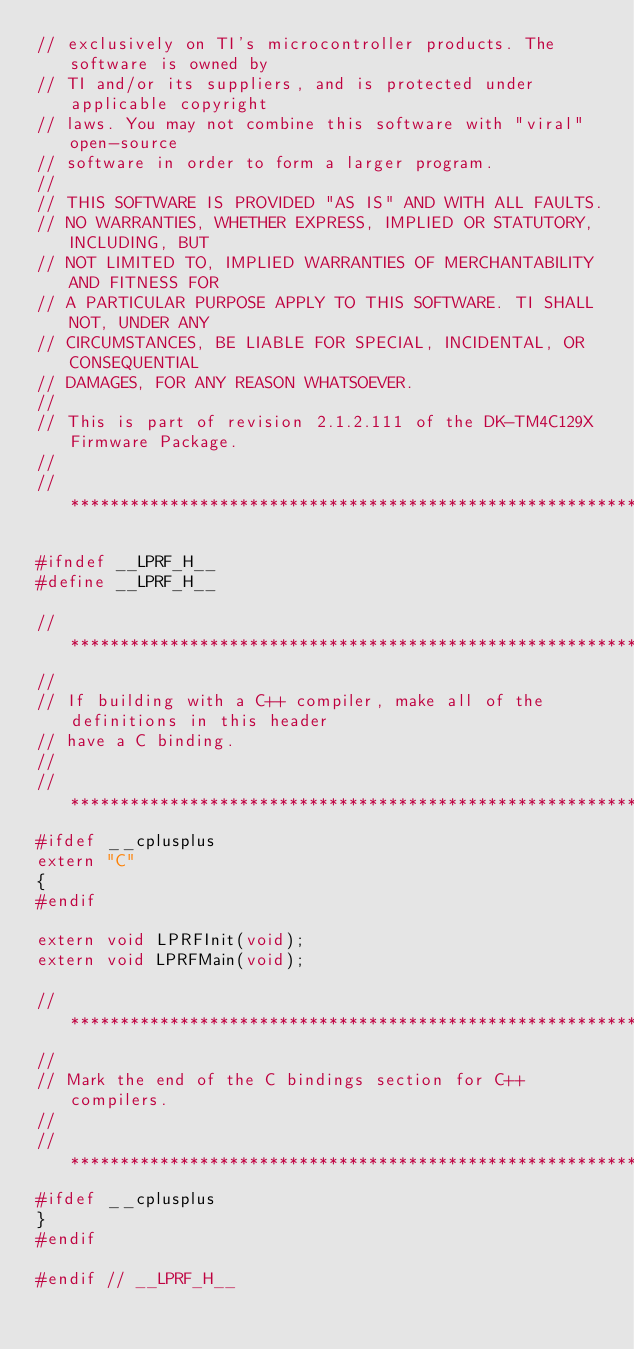<code> <loc_0><loc_0><loc_500><loc_500><_C_>// exclusively on TI's microcontroller products. The software is owned by
// TI and/or its suppliers, and is protected under applicable copyright
// laws. You may not combine this software with "viral" open-source
// software in order to form a larger program.
// 
// THIS SOFTWARE IS PROVIDED "AS IS" AND WITH ALL FAULTS.
// NO WARRANTIES, WHETHER EXPRESS, IMPLIED OR STATUTORY, INCLUDING, BUT
// NOT LIMITED TO, IMPLIED WARRANTIES OF MERCHANTABILITY AND FITNESS FOR
// A PARTICULAR PURPOSE APPLY TO THIS SOFTWARE. TI SHALL NOT, UNDER ANY
// CIRCUMSTANCES, BE LIABLE FOR SPECIAL, INCIDENTAL, OR CONSEQUENTIAL
// DAMAGES, FOR ANY REASON WHATSOEVER.
// 
// This is part of revision 2.1.2.111 of the DK-TM4C129X Firmware Package.
//
//*****************************************************************************

#ifndef __LPRF_H__
#define __LPRF_H__

//*****************************************************************************
//
// If building with a C++ compiler, make all of the definitions in this header
// have a C binding.
//
//*****************************************************************************
#ifdef __cplusplus
extern "C"
{
#endif

extern void LPRFInit(void);
extern void LPRFMain(void);

//*****************************************************************************
//
// Mark the end of the C bindings section for C++ compilers.
//
//*****************************************************************************
#ifdef __cplusplus
}
#endif

#endif // __LPRF_H__

</code> 